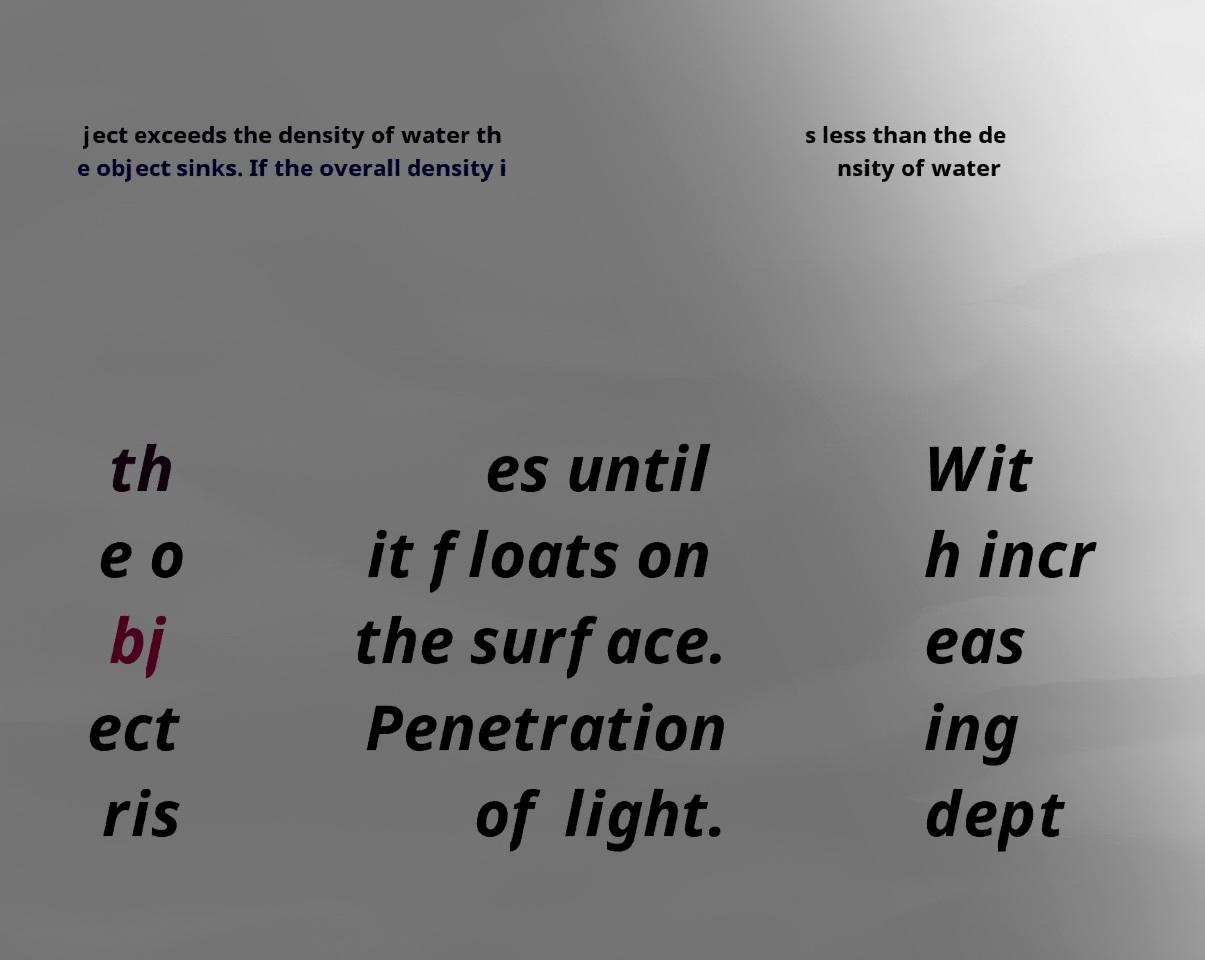For documentation purposes, I need the text within this image transcribed. Could you provide that? ject exceeds the density of water th e object sinks. If the overall density i s less than the de nsity of water th e o bj ect ris es until it floats on the surface. Penetration of light. Wit h incr eas ing dept 